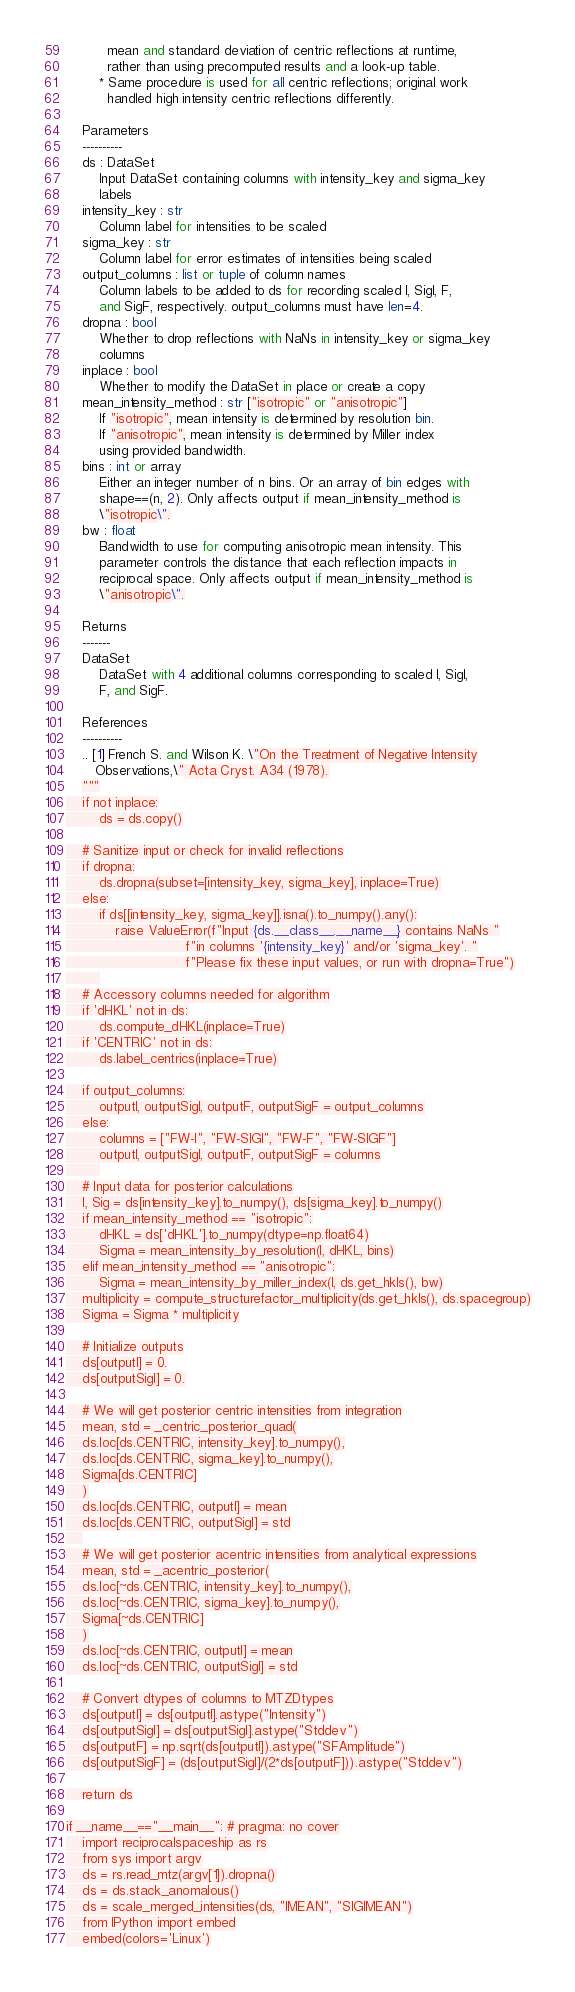Convert code to text. <code><loc_0><loc_0><loc_500><loc_500><_Python_>          mean and standard deviation of centric reflections at runtime, 
          rather than using precomputed results and a look-up table.
        * Same procedure is used for all centric reflections; original work 
          handled high intensity centric reflections differently.

    Parameters
    ----------
    ds : DataSet
        Input DataSet containing columns with intensity_key and sigma_key
        labels
    intensity_key : str
        Column label for intensities to be scaled
    sigma_key : str
        Column label for error estimates of intensities being scaled
    output_columns : list or tuple of column names
        Column labels to be added to ds for recording scaled I, SigI, F, 
        and SigF, respectively. output_columns must have len=4.
    dropna : bool
        Whether to drop reflections with NaNs in intensity_key or sigma_key
        columns
    inplace : bool
        Whether to modify the DataSet in place or create a copy
    mean_intensity_method : str ["isotropic" or "anisotropic"]
        If "isotropic", mean intensity is determined by resolution bin.
        If "anisotropic", mean intensity is determined by Miller index 
        using provided bandwidth.
    bins : int or array
        Either an integer number of n bins. Or an array of bin edges with 
        shape==(n, 2). Only affects output if mean_intensity_method is
        \"isotropic\".
    bw : float
        Bandwidth to use for computing anisotropic mean intensity. This 
        parameter controls the distance that each reflection impacts in 
        reciprocal space. Only affects output if mean_intensity_method is
        \"anisotropic\".

    Returns
    -------
    DataSet
        DataSet with 4 additional columns corresponding to scaled I, SigI,
        F, and SigF. 

    References
    ----------
    .. [1] French S. and Wilson K. \"On the Treatment of Negative Intensity
       Observations,\" Acta Cryst. A34 (1978).
    """
    if not inplace:
        ds = ds.copy()

    # Sanitize input or check for invalid reflections
    if dropna:
        ds.dropna(subset=[intensity_key, sigma_key], inplace=True)
    else:
        if ds[[intensity_key, sigma_key]].isna().to_numpy().any():
            raise ValueError(f"Input {ds.__class__.__name__} contains NaNs "
                             f"in columns '{intensity_key}' and/or 'sigma_key'. "
                             f"Please fix these input values, or run with dropna=True")
        
    # Accessory columns needed for algorithm
    if 'dHKL' not in ds:
        ds.compute_dHKL(inplace=True)
    if 'CENTRIC' not in ds:
        ds.label_centrics(inplace=True)

    if output_columns:
        outputI, outputSigI, outputF, outputSigF = output_columns
    else:
        columns = ["FW-I", "FW-SIGI", "FW-F", "FW-SIGF"]
        outputI, outputSigI, outputF, outputSigF = columns
        
    # Input data for posterior calculations
    I, Sig = ds[intensity_key].to_numpy(), ds[sigma_key].to_numpy()
    if mean_intensity_method == "isotropic":
        dHKL = ds['dHKL'].to_numpy(dtype=np.float64)
        Sigma = mean_intensity_by_resolution(I, dHKL, bins)
    elif mean_intensity_method == "anisotropic":
        Sigma = mean_intensity_by_miller_index(I, ds.get_hkls(), bw)
    multiplicity = compute_structurefactor_multiplicity(ds.get_hkls(), ds.spacegroup)
    Sigma = Sigma * multiplicity

    # Initialize outputs
    ds[outputI] = 0.
    ds[outputSigI] = 0.

    # We will get posterior centric intensities from integration
    mean, std = _centric_posterior_quad(
	ds.loc[ds.CENTRIC, intensity_key].to_numpy(),
	ds.loc[ds.CENTRIC, sigma_key].to_numpy(),
	Sigma[ds.CENTRIC]
    )
    ds.loc[ds.CENTRIC, outputI] = mean
    ds.loc[ds.CENTRIC, outputSigI] = std
    
    # We will get posterior acentric intensities from analytical expressions
    mean, std = _acentric_posterior(
	ds.loc[~ds.CENTRIC, intensity_key].to_numpy(),
	ds.loc[~ds.CENTRIC, sigma_key].to_numpy(),
	Sigma[~ds.CENTRIC]
    )
    ds.loc[~ds.CENTRIC, outputI] = mean
    ds.loc[~ds.CENTRIC, outputSigI] = std

    # Convert dtypes of columns to MTZDtypes
    ds[outputI] = ds[outputI].astype("Intensity")
    ds[outputSigI] = ds[outputSigI].astype("Stddev")
    ds[outputF] = np.sqrt(ds[outputI]).astype("SFAmplitude")
    ds[outputSigF] = (ds[outputSigI]/(2*ds[outputF])).astype("Stddev")

    return ds

if __name__=="__main__": # pragma: no cover
    import reciprocalspaceship as rs
    from sys import argv
    ds = rs.read_mtz(argv[1]).dropna()
    ds = ds.stack_anomalous()
    ds = scale_merged_intensities(ds, "IMEAN", "SIGIMEAN")
    from IPython import embed
    embed(colors='Linux')
</code> 